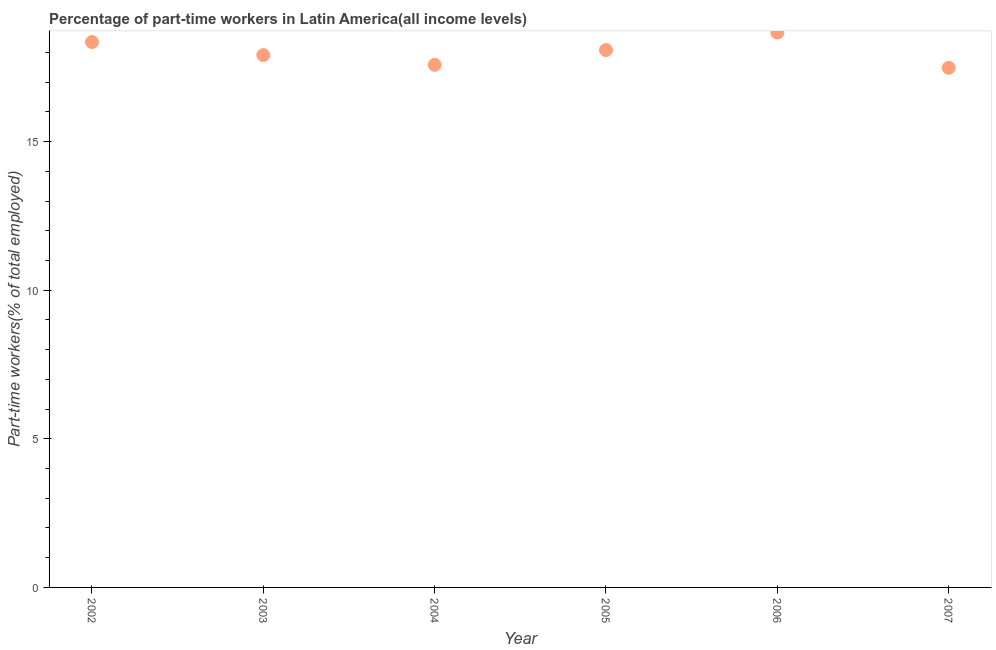What is the percentage of part-time workers in 2003?
Provide a short and direct response. 17.91. Across all years, what is the maximum percentage of part-time workers?
Ensure brevity in your answer.  18.67. Across all years, what is the minimum percentage of part-time workers?
Your answer should be very brief. 17.48. In which year was the percentage of part-time workers minimum?
Provide a short and direct response. 2007. What is the sum of the percentage of part-time workers?
Give a very brief answer. 108.07. What is the difference between the percentage of part-time workers in 2002 and 2006?
Provide a succinct answer. -0.32. What is the average percentage of part-time workers per year?
Provide a succinct answer. 18.01. What is the median percentage of part-time workers?
Your response must be concise. 18. In how many years, is the percentage of part-time workers greater than 7 %?
Provide a short and direct response. 6. Do a majority of the years between 2006 and 2003 (inclusive) have percentage of part-time workers greater than 7 %?
Provide a succinct answer. Yes. What is the ratio of the percentage of part-time workers in 2003 to that in 2007?
Provide a succinct answer. 1.02. Is the difference between the percentage of part-time workers in 2005 and 2007 greater than the difference between any two years?
Make the answer very short. No. What is the difference between the highest and the second highest percentage of part-time workers?
Give a very brief answer. 0.32. Is the sum of the percentage of part-time workers in 2004 and 2007 greater than the maximum percentage of part-time workers across all years?
Offer a terse response. Yes. What is the difference between the highest and the lowest percentage of part-time workers?
Offer a very short reply. 1.18. In how many years, is the percentage of part-time workers greater than the average percentage of part-time workers taken over all years?
Make the answer very short. 3. Does the percentage of part-time workers monotonically increase over the years?
Your response must be concise. No. Does the graph contain any zero values?
Keep it short and to the point. No. What is the title of the graph?
Keep it short and to the point. Percentage of part-time workers in Latin America(all income levels). What is the label or title of the Y-axis?
Your answer should be compact. Part-time workers(% of total employed). What is the Part-time workers(% of total employed) in 2002?
Your answer should be compact. 18.35. What is the Part-time workers(% of total employed) in 2003?
Keep it short and to the point. 17.91. What is the Part-time workers(% of total employed) in 2004?
Your response must be concise. 17.58. What is the Part-time workers(% of total employed) in 2005?
Provide a short and direct response. 18.08. What is the Part-time workers(% of total employed) in 2006?
Provide a succinct answer. 18.67. What is the Part-time workers(% of total employed) in 2007?
Your answer should be very brief. 17.48. What is the difference between the Part-time workers(% of total employed) in 2002 and 2003?
Your answer should be very brief. 0.44. What is the difference between the Part-time workers(% of total employed) in 2002 and 2004?
Your answer should be compact. 0.77. What is the difference between the Part-time workers(% of total employed) in 2002 and 2005?
Keep it short and to the point. 0.27. What is the difference between the Part-time workers(% of total employed) in 2002 and 2006?
Keep it short and to the point. -0.32. What is the difference between the Part-time workers(% of total employed) in 2002 and 2007?
Offer a terse response. 0.87. What is the difference between the Part-time workers(% of total employed) in 2003 and 2004?
Your answer should be very brief. 0.33. What is the difference between the Part-time workers(% of total employed) in 2003 and 2005?
Ensure brevity in your answer.  -0.17. What is the difference between the Part-time workers(% of total employed) in 2003 and 2006?
Make the answer very short. -0.76. What is the difference between the Part-time workers(% of total employed) in 2003 and 2007?
Your answer should be very brief. 0.43. What is the difference between the Part-time workers(% of total employed) in 2004 and 2005?
Offer a very short reply. -0.5. What is the difference between the Part-time workers(% of total employed) in 2004 and 2006?
Provide a succinct answer. -1.09. What is the difference between the Part-time workers(% of total employed) in 2004 and 2007?
Keep it short and to the point. 0.1. What is the difference between the Part-time workers(% of total employed) in 2005 and 2006?
Provide a succinct answer. -0.59. What is the difference between the Part-time workers(% of total employed) in 2005 and 2007?
Offer a terse response. 0.6. What is the difference between the Part-time workers(% of total employed) in 2006 and 2007?
Keep it short and to the point. 1.18. What is the ratio of the Part-time workers(% of total employed) in 2002 to that in 2003?
Offer a terse response. 1.02. What is the ratio of the Part-time workers(% of total employed) in 2002 to that in 2004?
Offer a terse response. 1.04. What is the ratio of the Part-time workers(% of total employed) in 2002 to that in 2005?
Offer a terse response. 1.01. What is the ratio of the Part-time workers(% of total employed) in 2002 to that in 2007?
Keep it short and to the point. 1.05. What is the ratio of the Part-time workers(% of total employed) in 2003 to that in 2004?
Keep it short and to the point. 1.02. What is the ratio of the Part-time workers(% of total employed) in 2003 to that in 2005?
Your response must be concise. 0.99. What is the ratio of the Part-time workers(% of total employed) in 2003 to that in 2006?
Your response must be concise. 0.96. What is the ratio of the Part-time workers(% of total employed) in 2003 to that in 2007?
Your answer should be very brief. 1.02. What is the ratio of the Part-time workers(% of total employed) in 2004 to that in 2005?
Ensure brevity in your answer.  0.97. What is the ratio of the Part-time workers(% of total employed) in 2004 to that in 2006?
Offer a terse response. 0.94. What is the ratio of the Part-time workers(% of total employed) in 2005 to that in 2007?
Offer a very short reply. 1.03. What is the ratio of the Part-time workers(% of total employed) in 2006 to that in 2007?
Provide a short and direct response. 1.07. 